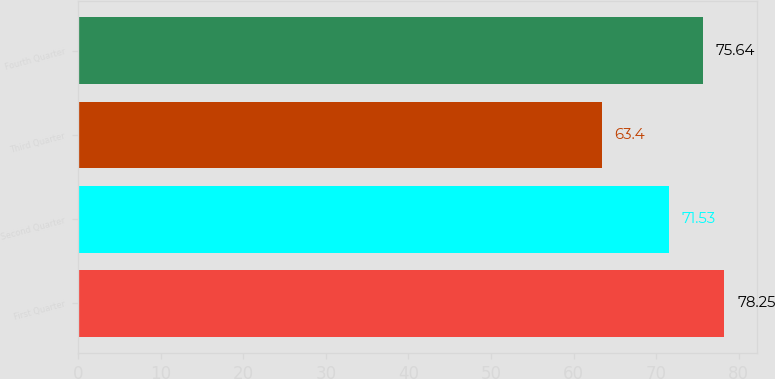<chart> <loc_0><loc_0><loc_500><loc_500><bar_chart><fcel>First Quarter<fcel>Second Quarter<fcel>Third Quarter<fcel>Fourth Quarter<nl><fcel>78.25<fcel>71.53<fcel>63.4<fcel>75.64<nl></chart> 